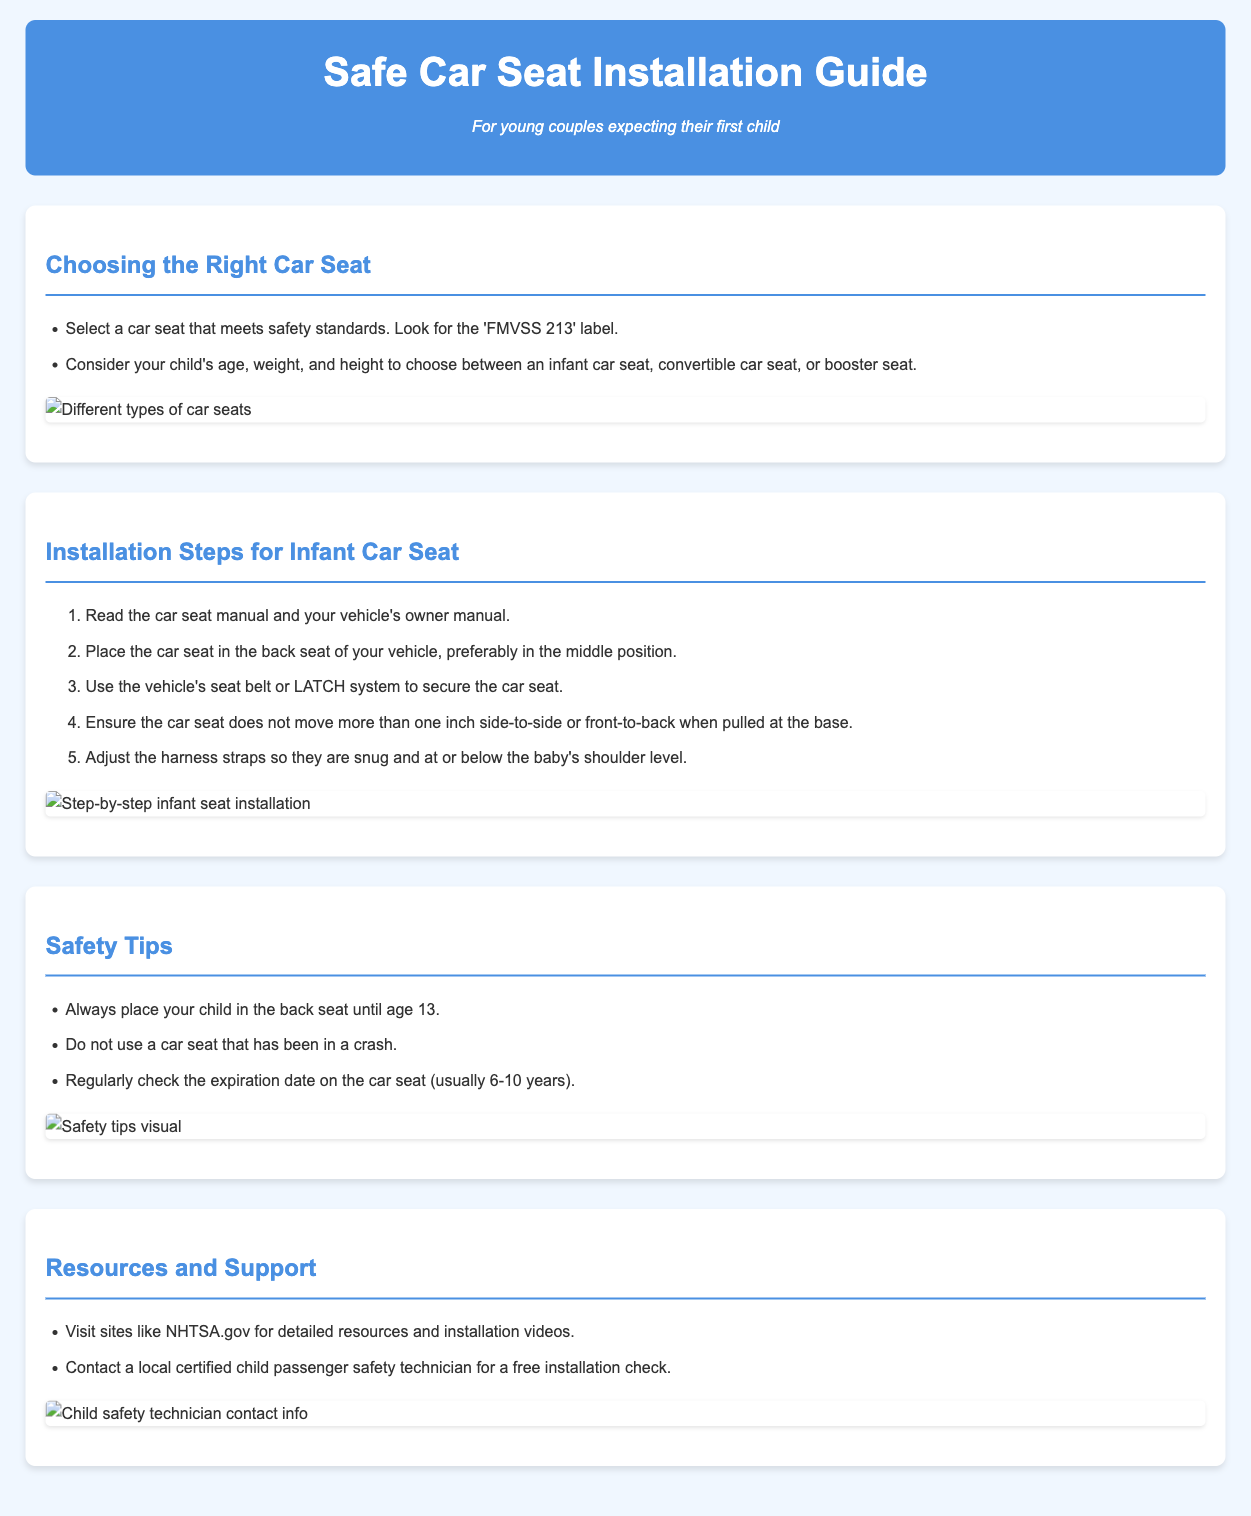What is the title of the guide? The title of the guide is prominently displayed at the top of the document.
Answer: Safe Car Seat Installation Guide What should you check to ensure a car seat meets safety standards? The document specifies the 'FMVSS 213' label as a criterion for safety standards.
Answer: 'FMVSS 213' label Where should the car seat be placed in the vehicle? The guide recommends placing the car seat in the back seat, preferably in the middle position.
Answer: Back seat, middle position What should you do if the car seat moves more than one inch? The installation guide states that if the car seat moves more than one inch side-to-side or front-to-back, then adjustments are necessary.
Answer: Adjustments are necessary What is a recommended resource for installation videos? The document suggests visiting NHTSA.gov for detailed resources and installation videos.
Answer: NHTSA.gov How many years is the typical expiration date of a car seat? The safe usage duration of a car seat is outlined in the document, indicating it is usually 6-10 years.
Answer: 6-10 years What should you do if a car seat has been in a crash? The guide clearly states that you should not use a car seat that has been in a crash.
Answer: Do not use Who can provide a free installation check? The document mentions contacting a local certified child passenger safety technician for help.
Answer: Certified child passenger safety technician 